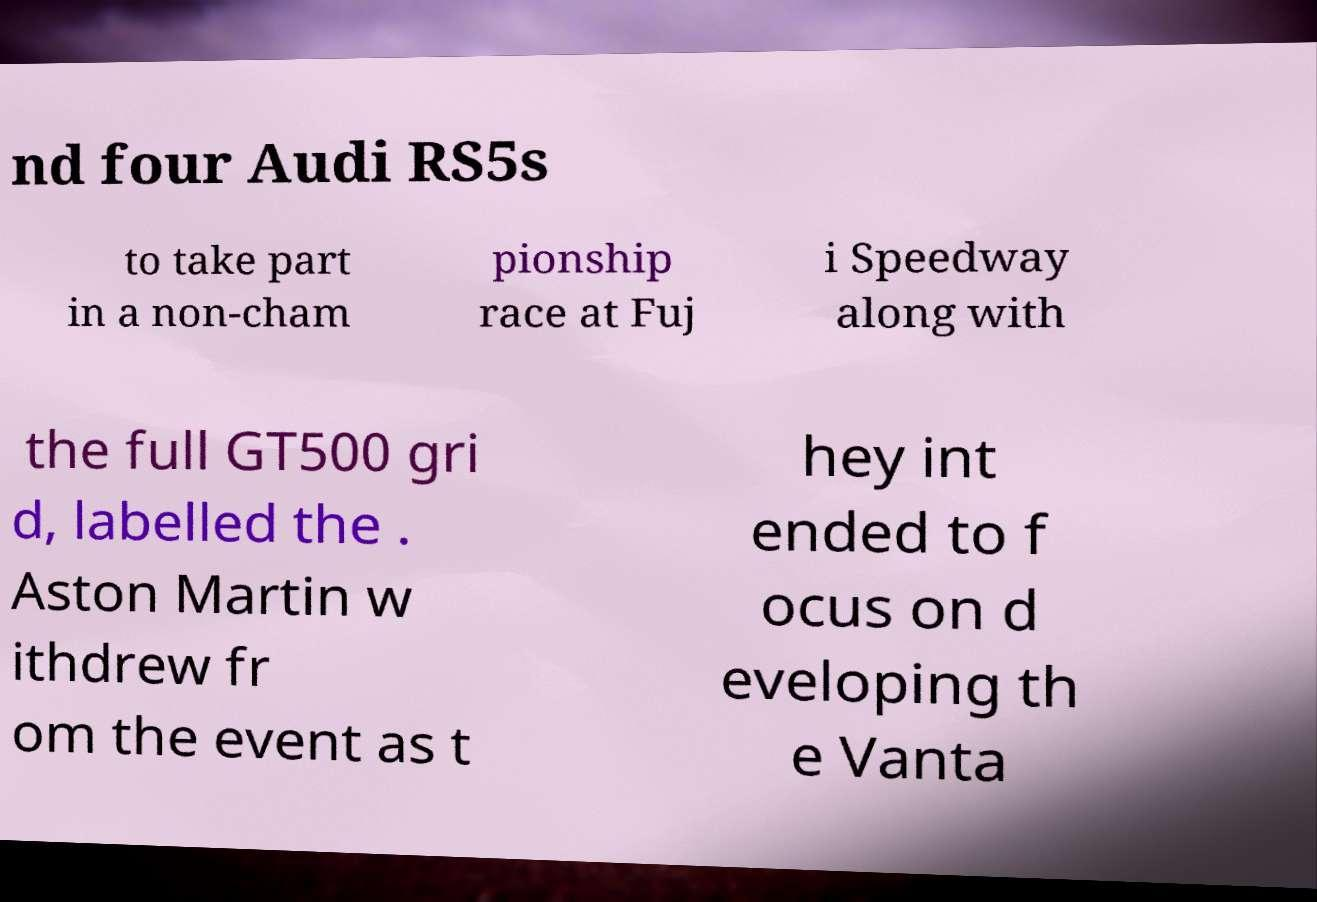Can you read and provide the text displayed in the image?This photo seems to have some interesting text. Can you extract and type it out for me? nd four Audi RS5s to take part in a non-cham pionship race at Fuj i Speedway along with the full GT500 gri d, labelled the . Aston Martin w ithdrew fr om the event as t hey int ended to f ocus on d eveloping th e Vanta 